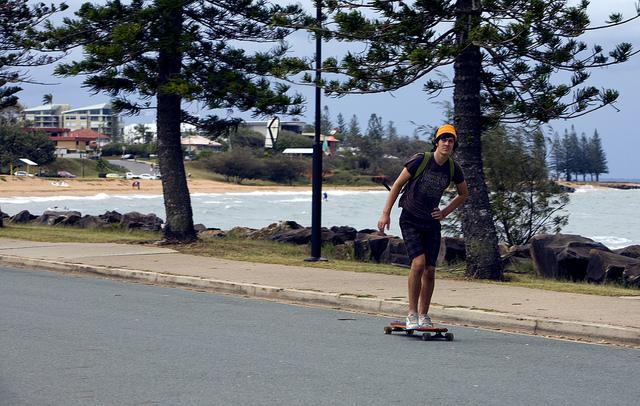Are shadows cast?
Write a very short answer. No. Is this street near water?
Short answer required. Yes. Is the skateboarder wearing shorts?
Give a very brief answer. Yes. Is the man wearing socks?
Concise answer only. Yes. How many trees do you see?
Concise answer only. 2. Is there a parking lot in the scene?
Answer briefly. No. Do these trees grow leaves?
Keep it brief. No. What is on the heads?
Write a very short answer. Hat. 